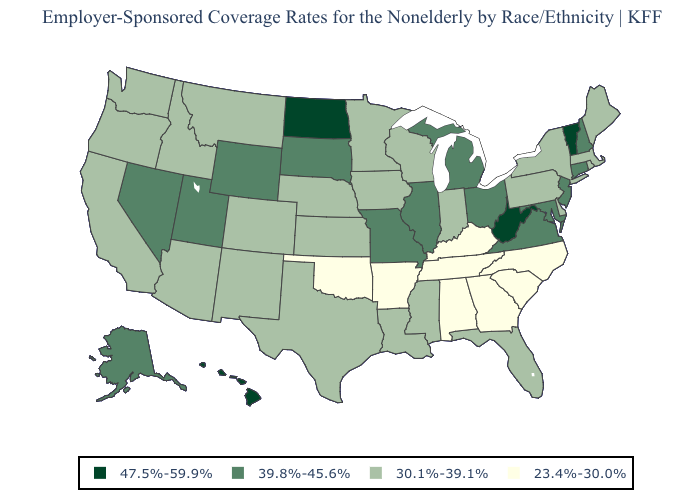Name the states that have a value in the range 39.8%-45.6%?
Give a very brief answer. Alaska, Connecticut, Illinois, Maryland, Michigan, Missouri, Nevada, New Hampshire, New Jersey, Ohio, South Dakota, Utah, Virginia, Wyoming. Name the states that have a value in the range 39.8%-45.6%?
Short answer required. Alaska, Connecticut, Illinois, Maryland, Michigan, Missouri, Nevada, New Hampshire, New Jersey, Ohio, South Dakota, Utah, Virginia, Wyoming. Does South Carolina have a lower value than Virginia?
Short answer required. Yes. Does North Dakota have the lowest value in the MidWest?
Short answer required. No. Name the states that have a value in the range 30.1%-39.1%?
Keep it brief. Arizona, California, Colorado, Delaware, Florida, Idaho, Indiana, Iowa, Kansas, Louisiana, Maine, Massachusetts, Minnesota, Mississippi, Montana, Nebraska, New Mexico, New York, Oregon, Pennsylvania, Rhode Island, Texas, Washington, Wisconsin. Name the states that have a value in the range 30.1%-39.1%?
Answer briefly. Arizona, California, Colorado, Delaware, Florida, Idaho, Indiana, Iowa, Kansas, Louisiana, Maine, Massachusetts, Minnesota, Mississippi, Montana, Nebraska, New Mexico, New York, Oregon, Pennsylvania, Rhode Island, Texas, Washington, Wisconsin. Which states have the lowest value in the USA?
Answer briefly. Alabama, Arkansas, Georgia, Kentucky, North Carolina, Oklahoma, South Carolina, Tennessee. Name the states that have a value in the range 23.4%-30.0%?
Concise answer only. Alabama, Arkansas, Georgia, Kentucky, North Carolina, Oklahoma, South Carolina, Tennessee. What is the value of Montana?
Write a very short answer. 30.1%-39.1%. What is the value of South Dakota?
Keep it brief. 39.8%-45.6%. What is the value of Colorado?
Be succinct. 30.1%-39.1%. What is the highest value in the USA?
Concise answer only. 47.5%-59.9%. Among the states that border Delaware , does Pennsylvania have the lowest value?
Answer briefly. Yes. What is the value of Wyoming?
Short answer required. 39.8%-45.6%. Does New Mexico have the same value as Kansas?
Keep it brief. Yes. 